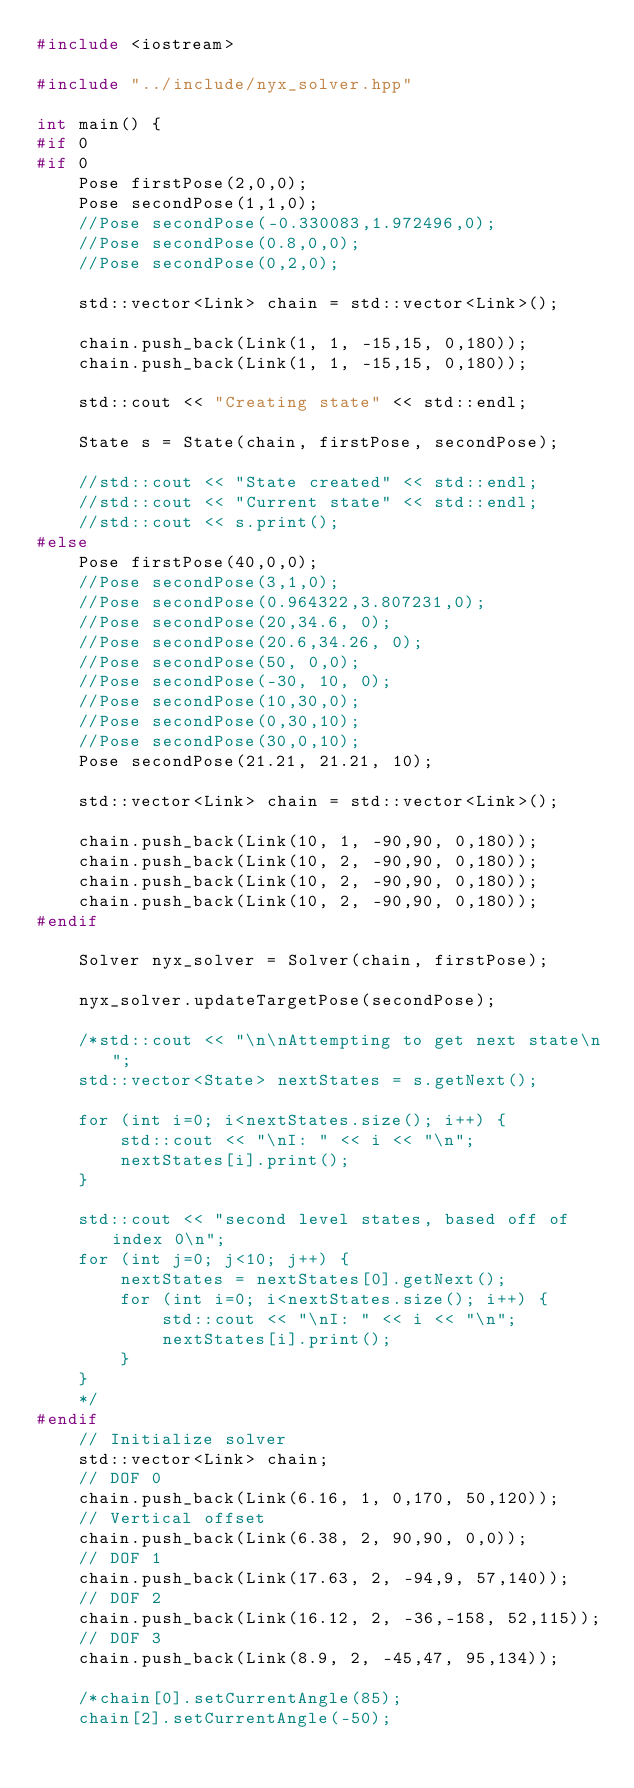<code> <loc_0><loc_0><loc_500><loc_500><_C++_>#include <iostream>

#include "../include/nyx_solver.hpp"

int main() {
#if 0
#if 0
    Pose firstPose(2,0,0);
    Pose secondPose(1,1,0);
    //Pose secondPose(-0.330083,1.972496,0);
    //Pose secondPose(0.8,0,0);
    //Pose secondPose(0,2,0);

    std::vector<Link> chain = std::vector<Link>();

    chain.push_back(Link(1, 1, -15,15, 0,180));
    chain.push_back(Link(1, 1, -15,15, 0,180));

    std::cout << "Creating state" << std::endl;

    State s = State(chain, firstPose, secondPose);

    //std::cout << "State created" << std::endl;
    //std::cout << "Current state" << std::endl;
    //std::cout << s.print();
#else
    Pose firstPose(40,0,0);
    //Pose secondPose(3,1,0);
    //Pose secondPose(0.964322,3.807231,0);
    //Pose secondPose(20,34.6, 0);
    //Pose secondPose(20.6,34.26, 0);
    //Pose secondPose(50, 0,0);
    //Pose secondPose(-30, 10, 0);
    //Pose secondPose(10,30,0);
    //Pose secondPose(0,30,10);
    //Pose secondPose(30,0,10);
    Pose secondPose(21.21, 21.21, 10);

    std::vector<Link> chain = std::vector<Link>();

    chain.push_back(Link(10, 1, -90,90, 0,180));
    chain.push_back(Link(10, 2, -90,90, 0,180));
    chain.push_back(Link(10, 2, -90,90, 0,180));
    chain.push_back(Link(10, 2, -90,90, 0,180));
#endif

    Solver nyx_solver = Solver(chain, firstPose);

    nyx_solver.updateTargetPose(secondPose);

    /*std::cout << "\n\nAttempting to get next state\n";
    std::vector<State> nextStates = s.getNext();

    for (int i=0; i<nextStates.size(); i++) {
        std::cout << "\nI: " << i << "\n";
        nextStates[i].print();
    }

    std::cout << "second level states, based off of index 0\n";
    for (int j=0; j<10; j++) {
        nextStates = nextStates[0].getNext();
        for (int i=0; i<nextStates.size(); i++) {
            std::cout << "\nI: " << i << "\n";
            nextStates[i].print();
        }
    }
    */
#endif
    // Initialize solver
    std::vector<Link> chain;
    // DOF 0
    chain.push_back(Link(6.16, 1, 0,170, 50,120));
    // Vertical offset
    chain.push_back(Link(6.38, 2, 90,90, 0,0));
    // DOF 1
    chain.push_back(Link(17.63, 2, -94,9, 57,140));
    // DOF 2
    chain.push_back(Link(16.12, 2, -36,-158, 52,115));
    // DOF 3
    chain.push_back(Link(8.9, 2, -45,47, 95,134));

    /*chain[0].setCurrentAngle(85);
    chain[2].setCurrentAngle(-50);</code> 